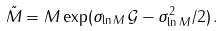<formula> <loc_0><loc_0><loc_500><loc_500>\tilde { M } = M \exp ( \sigma _ { \ln M } \, \mathcal { G } - \sigma _ { \ln M } ^ { 2 } / 2 ) \, .</formula> 